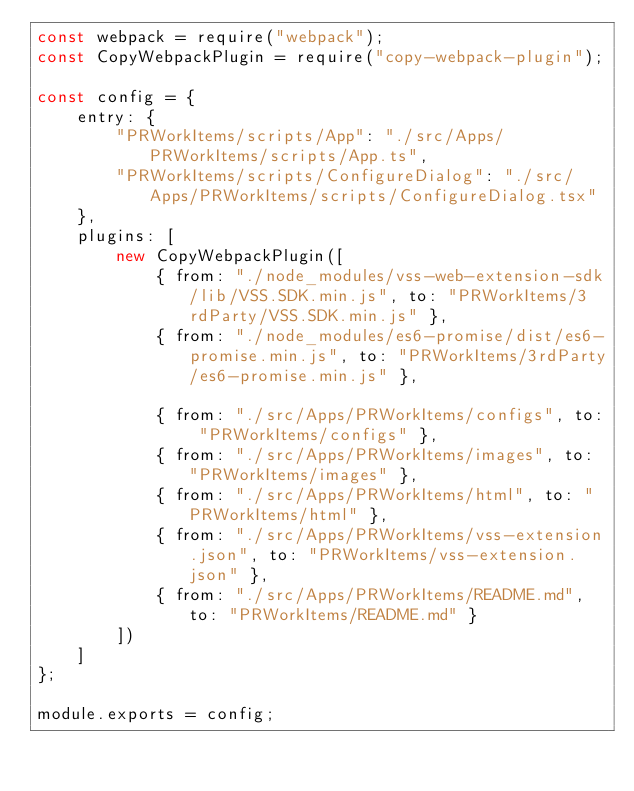Convert code to text. <code><loc_0><loc_0><loc_500><loc_500><_JavaScript_>const webpack = require("webpack");
const CopyWebpackPlugin = require("copy-webpack-plugin");

const config = {
    entry: {
        "PRWorkItems/scripts/App": "./src/Apps/PRWorkItems/scripts/App.ts",
        "PRWorkItems/scripts/ConfigureDialog": "./src/Apps/PRWorkItems/scripts/ConfigureDialog.tsx"
    },
    plugins: [
        new CopyWebpackPlugin([
            { from: "./node_modules/vss-web-extension-sdk/lib/VSS.SDK.min.js", to: "PRWorkItems/3rdParty/VSS.SDK.min.js" },
            { from: "./node_modules/es6-promise/dist/es6-promise.min.js", to: "PRWorkItems/3rdParty/es6-promise.min.js" },

            { from: "./src/Apps/PRWorkItems/configs", to: "PRWorkItems/configs" },
            { from: "./src/Apps/PRWorkItems/images", to: "PRWorkItems/images" },
            { from: "./src/Apps/PRWorkItems/html", to: "PRWorkItems/html" },
            { from: "./src/Apps/PRWorkItems/vss-extension.json", to: "PRWorkItems/vss-extension.json" },
            { from: "./src/Apps/PRWorkItems/README.md", to: "PRWorkItems/README.md" }
        ])
    ]
};

module.exports = config;
</code> 